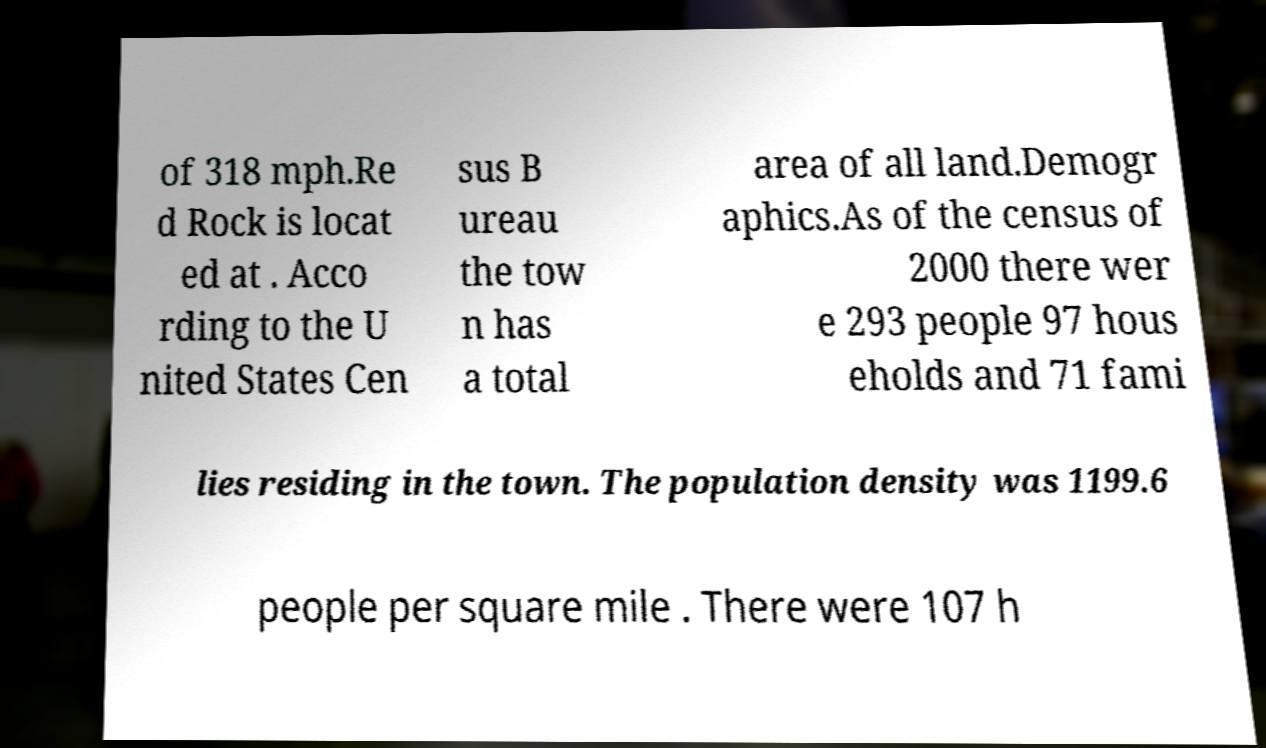Can you accurately transcribe the text from the provided image for me? of 318 mph.Re d Rock is locat ed at . Acco rding to the U nited States Cen sus B ureau the tow n has a total area of all land.Demogr aphics.As of the census of 2000 there wer e 293 people 97 hous eholds and 71 fami lies residing in the town. The population density was 1199.6 people per square mile . There were 107 h 